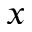Convert formula to latex. <formula><loc_0><loc_0><loc_500><loc_500>x</formula> 